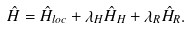Convert formula to latex. <formula><loc_0><loc_0><loc_500><loc_500>\hat { H } = \hat { H } _ { l o c } + \lambda _ { H } \hat { H } _ { H } + \lambda _ { R } \hat { H } _ { R } .</formula> 